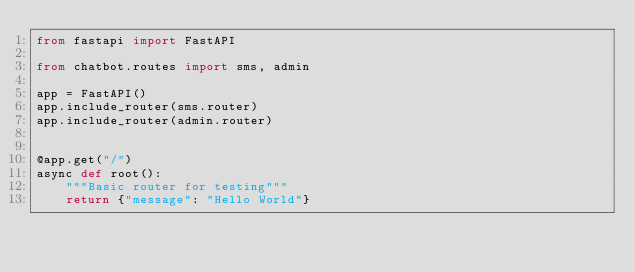<code> <loc_0><loc_0><loc_500><loc_500><_Python_>from fastapi import FastAPI

from chatbot.routes import sms, admin

app = FastAPI()
app.include_router(sms.router)
app.include_router(admin.router)


@app.get("/")
async def root():
    """Basic router for testing"""
    return {"message": "Hello World"}
</code> 